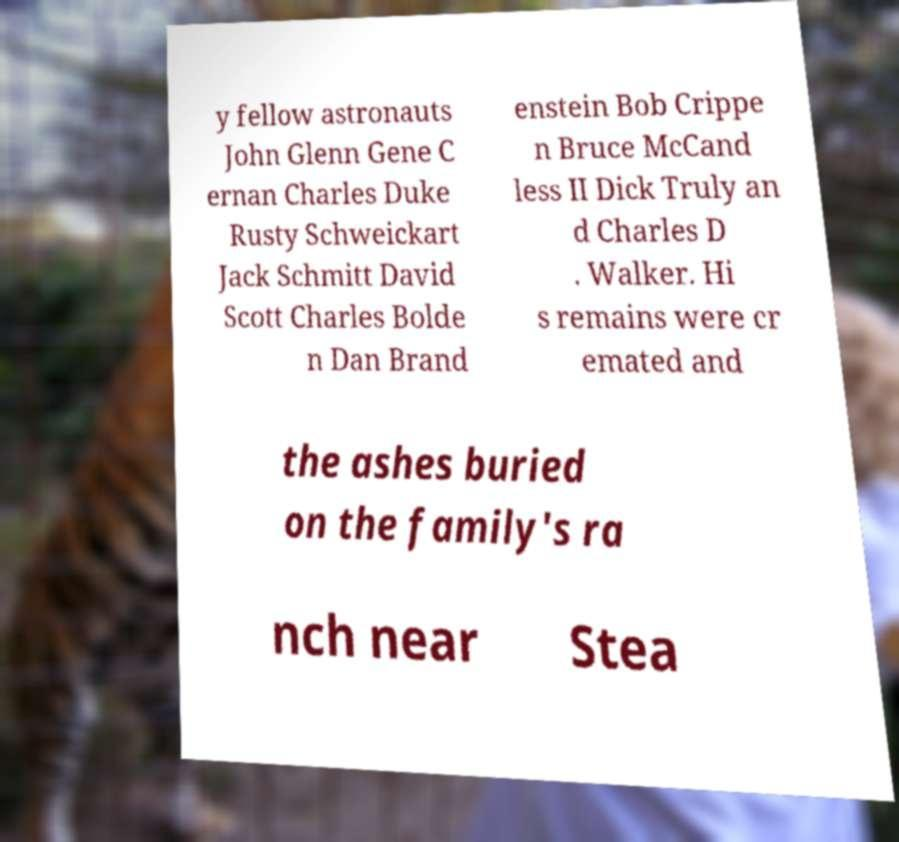What messages or text are displayed in this image? I need them in a readable, typed format. y fellow astronauts John Glenn Gene C ernan Charles Duke Rusty Schweickart Jack Schmitt David Scott Charles Bolde n Dan Brand enstein Bob Crippe n Bruce McCand less II Dick Truly an d Charles D . Walker. Hi s remains were cr emated and the ashes buried on the family's ra nch near Stea 